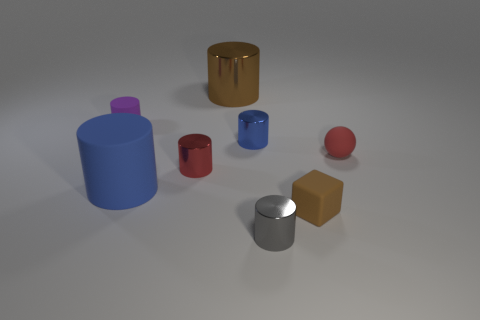Subtract all brown cylinders. How many cylinders are left? 5 Subtract all large brown metal cylinders. How many cylinders are left? 5 Subtract all yellow cylinders. Subtract all yellow blocks. How many cylinders are left? 6 Add 1 red cylinders. How many objects exist? 9 Subtract all cylinders. How many objects are left? 2 Subtract 0 yellow cubes. How many objects are left? 8 Subtract all tiny purple matte things. Subtract all large metal cylinders. How many objects are left? 6 Add 4 rubber spheres. How many rubber spheres are left? 5 Add 7 green matte things. How many green matte things exist? 7 